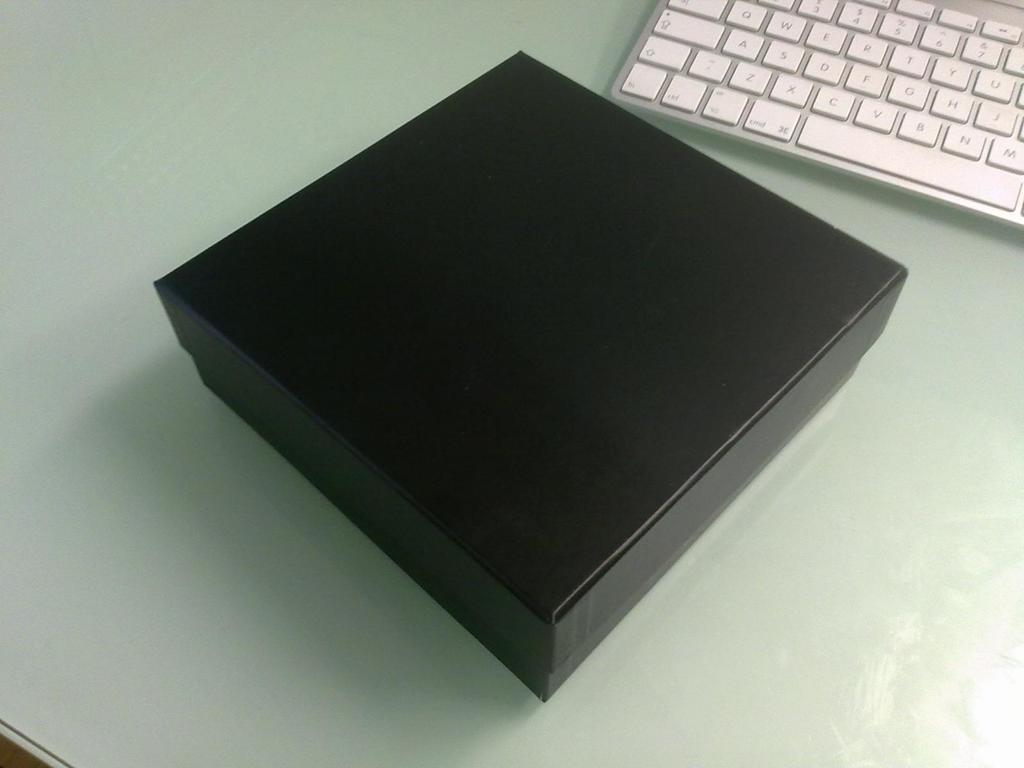What object in the image is black? There is a black box in the image. What type of device is visible in the image? There is a keyboard in the image. Where is the keyboard located? The keyboard is on a table. How many children are playing with the black box in the image? There are no children present in the image, and the black box is not being played with. What is the range of the keyboard in the image? The range of the keyboard cannot be determined from the image alone, as it depends on the specific model and its capabilities. 